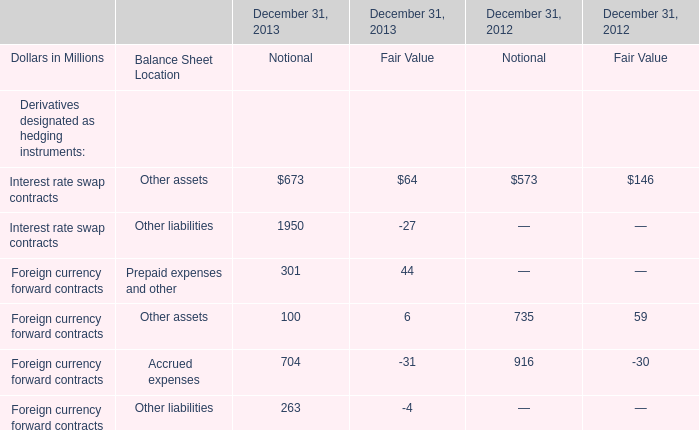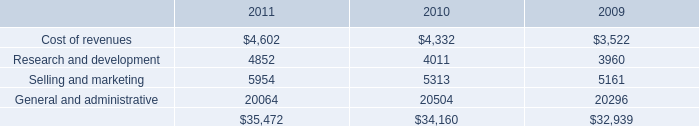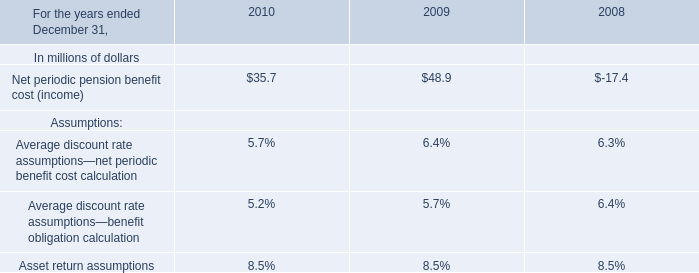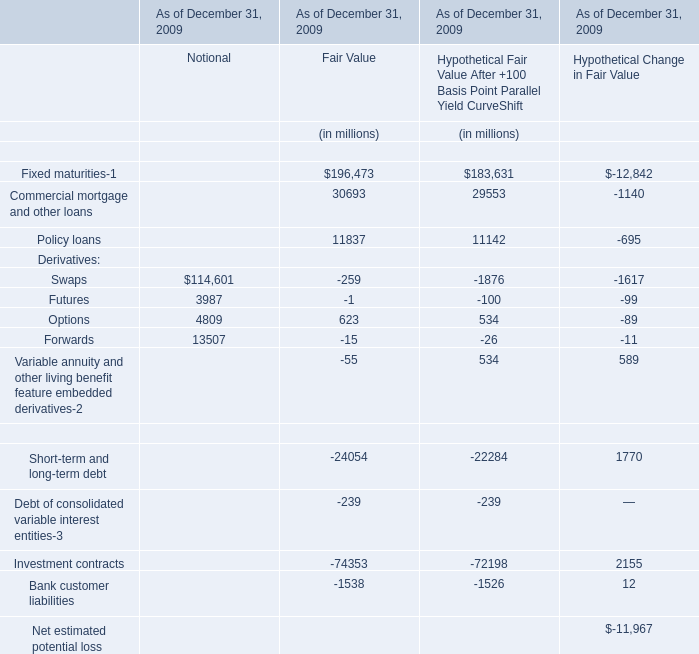What is the ratio of all elements that are smaller than 10000 to the sum of elements, for Notional? 
Computations: ((3987 + 4809) / (((114601 + 3987) + 4809) + 13507))
Answer: 0.06425. 